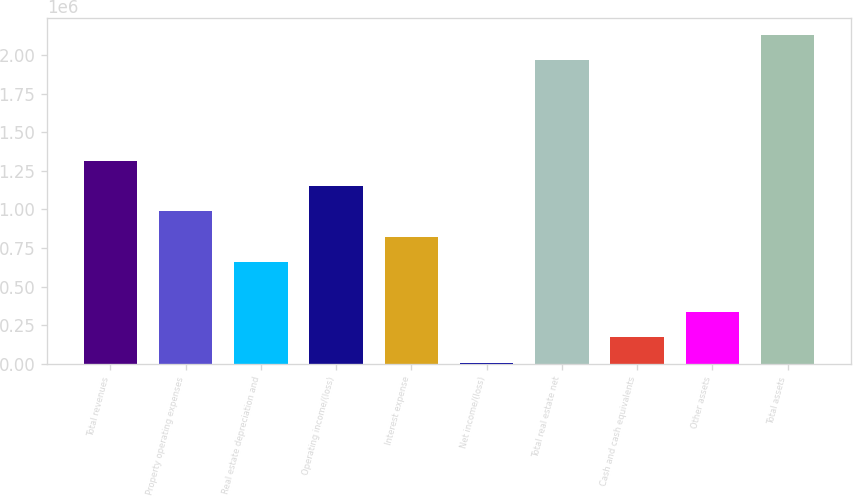<chart> <loc_0><loc_0><loc_500><loc_500><bar_chart><fcel>Total revenues<fcel>Property operating expenses<fcel>Real estate depreciation and<fcel>Operating income/(loss)<fcel>Interest expense<fcel>Net income/(loss)<fcel>Total real estate net<fcel>Cash and cash equivalents<fcel>Other assets<fcel>Total assets<nl><fcel>1.31351e+06<fcel>987257<fcel>661004<fcel>1.15038e+06<fcel>824130<fcel>8496<fcel>1.96602e+06<fcel>171623<fcel>334750<fcel>2.12915e+06<nl></chart> 